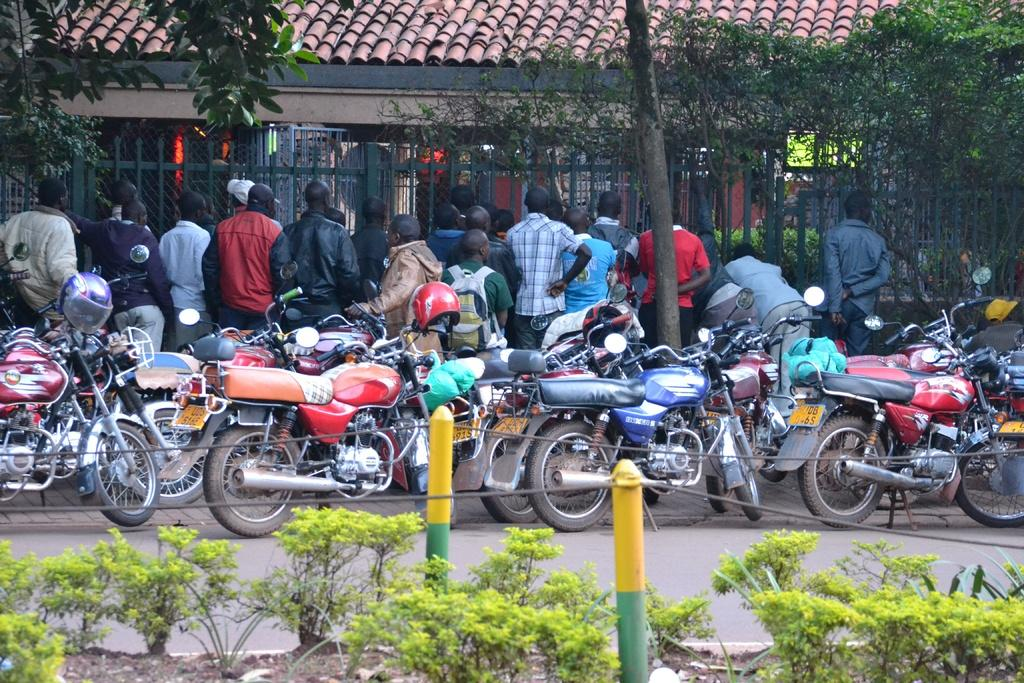What type of vehicles are in the image? There are motorcycles in the image. What else can be seen in the image besides the motorcycles? There are people standing, a house, trees, a metal fence, and plants in the image. Can you describe the fence in the image? The fence in the image is made of metal. What type of vegetation is present in the image? There are trees and plants in the image. What type of thread is being used to sew the motorcycles together in the image? There is no thread or sewing activity present in the image; it shows motorcycles, people, a house, trees, a metal fence, and plants. 